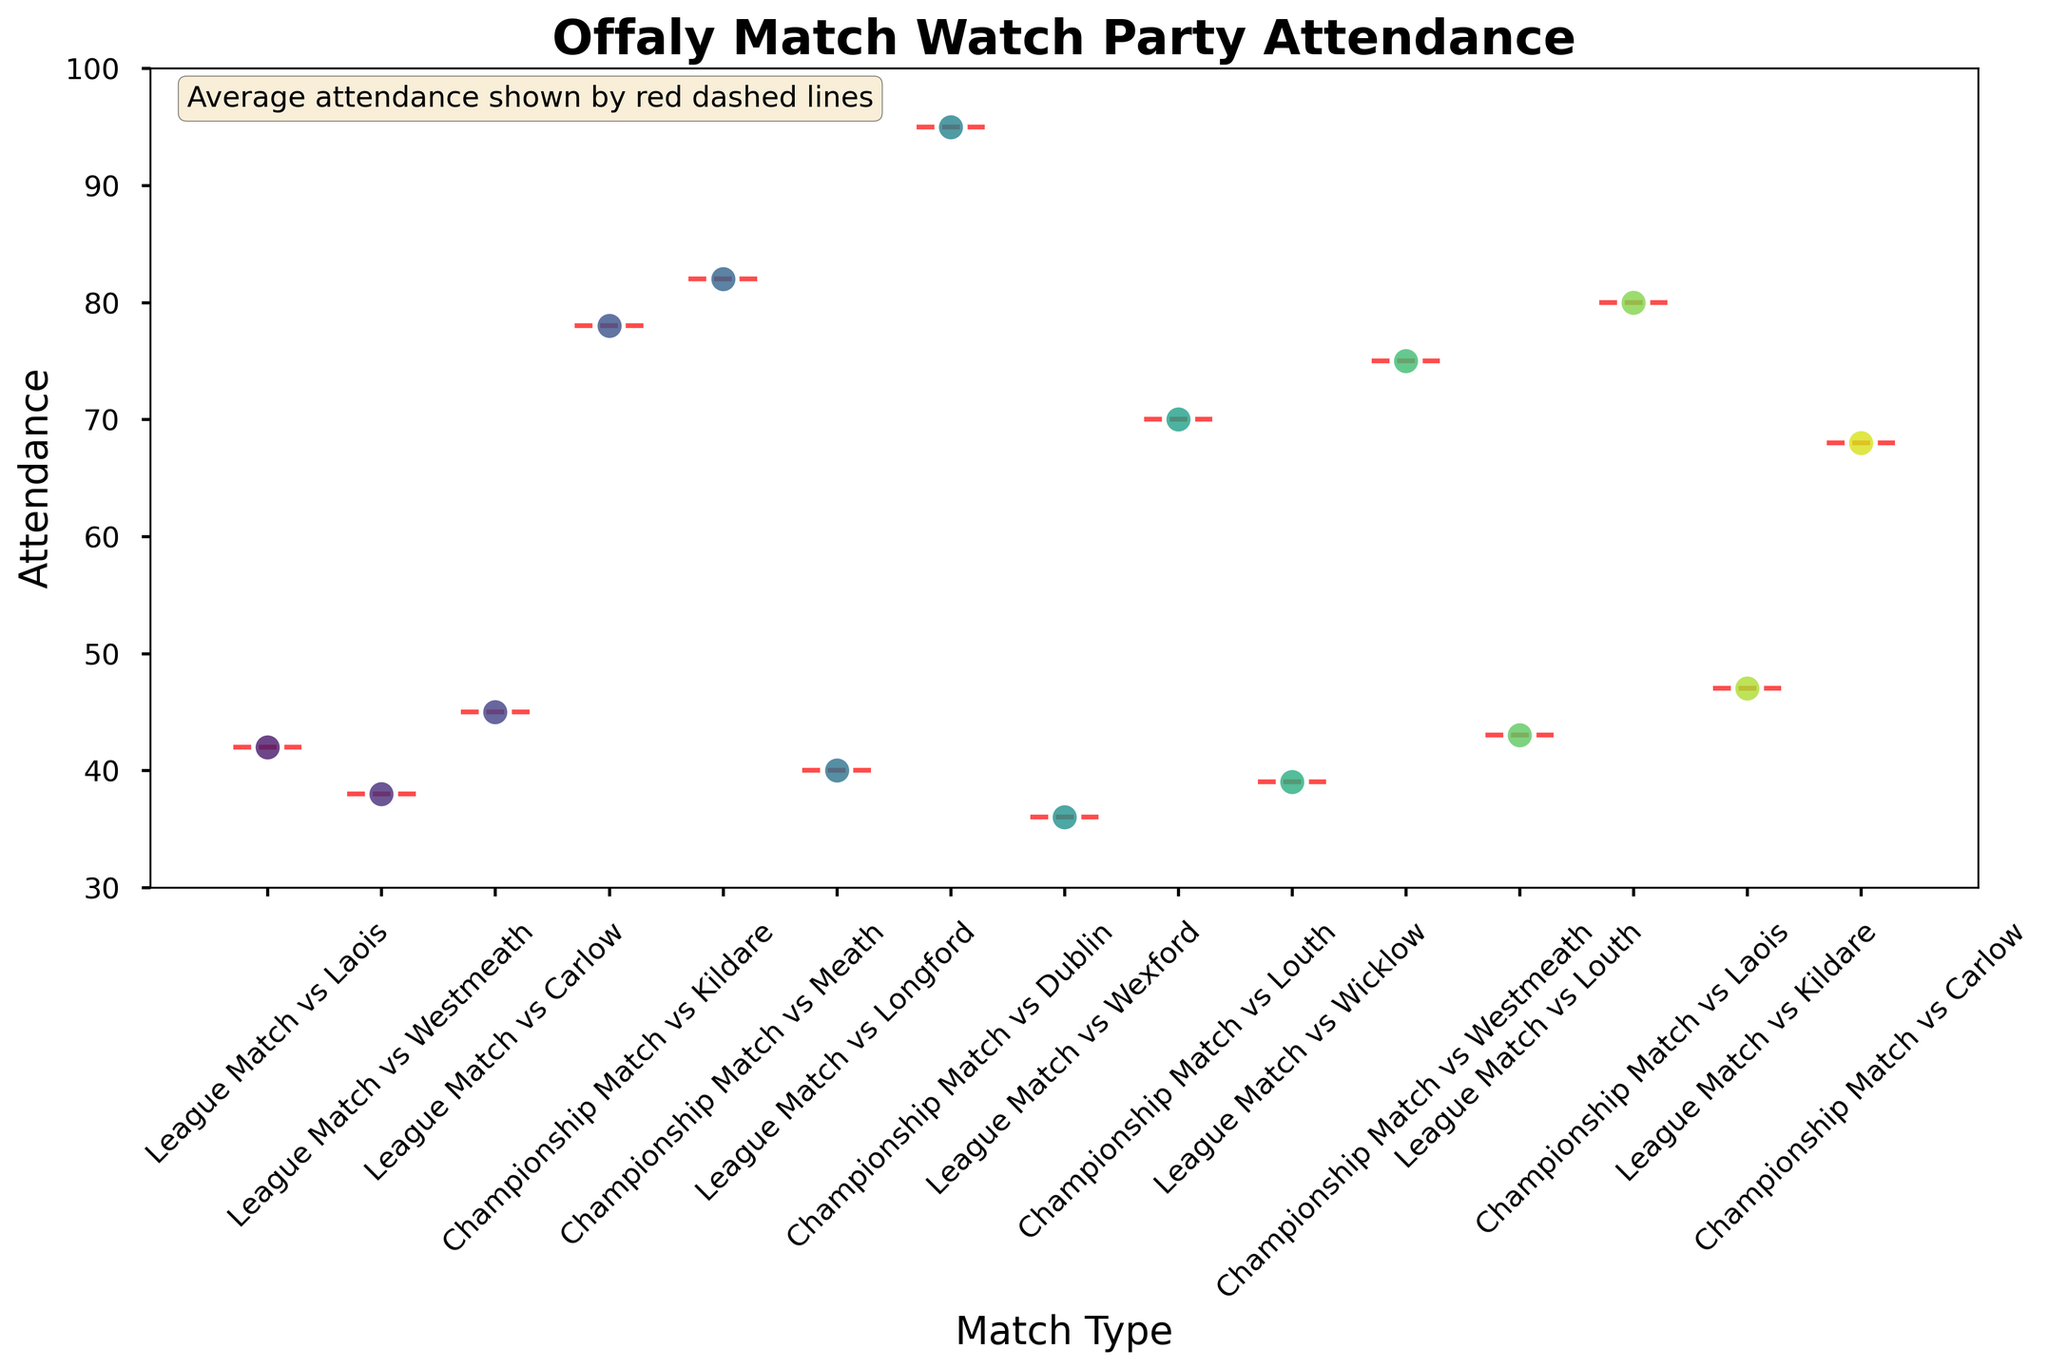What's the title of the figure? The title of the figure is displayed in bold at the top of the figure. It reads 'Offaly Match Watch Party Attendance'.
Answer: Offaly Match Watch Party Attendance What is the y-axis label? The y-axis label is found along the vertical axis of the figure and it reads 'Attendance'.
Answer: Attendance How are the match types differentiated in the plot? The match types are differentiated by their names on the x-axis which are rotated at a 45-degree angle for readability. Each match type shows individual points representing attendance.
Answer: By names on the x-axis What is the average attendance for Championship Matches vs Laois? The figure has red dashed lines showing the average attendance. For Championship Matches vs Laois, identify the red dashed line at the corresponding x-axis category.
Answer: 80 Which match had the highest attendance? Look at the y-axis values and find the point that reaches the highest value. It falls under the category 'Championship Match vs Dublin'.
Answer: Championship Match vs Dublin Compare the average attendance between League Matches and Championship Matches. Which one is higher? Calculate the average attendance for all League Matches and Championship Matches separately by looking at where the red dashed lines fall. Championship Matches generally have higher average attendances than League Matches.
Answer: Championship Matches Are there more data points representing League Matches or Championship Matches? Count the swarm points under each category. There are 8 data points for League Matches and 7 for Championship Matches.
Answer: League Matches What's the range of attendance values for Championship Matches? Identify the lowest and highest points for the Championship Matches on the y-axis. The lowest is 68, and the highest is 95. So, the range is 95 - 68.
Answer: 27 Is the attendance for the Championship Match vs Kildare above or below the average attendance for Championship Matches? Compare the data point for Championship Match vs Kildare (78) with the average attendance line for Championship Matches (around 80). It is slightly below the average.
Answer: Below Which Championship Match has the lowest attendance, and what is its value? Look for the lowest point among the Championship Matches categories. The lowest attendance is under the 'Championship Match vs Carlow' category.
Answer: Championship Match vs Carlow with an attendance of 68 